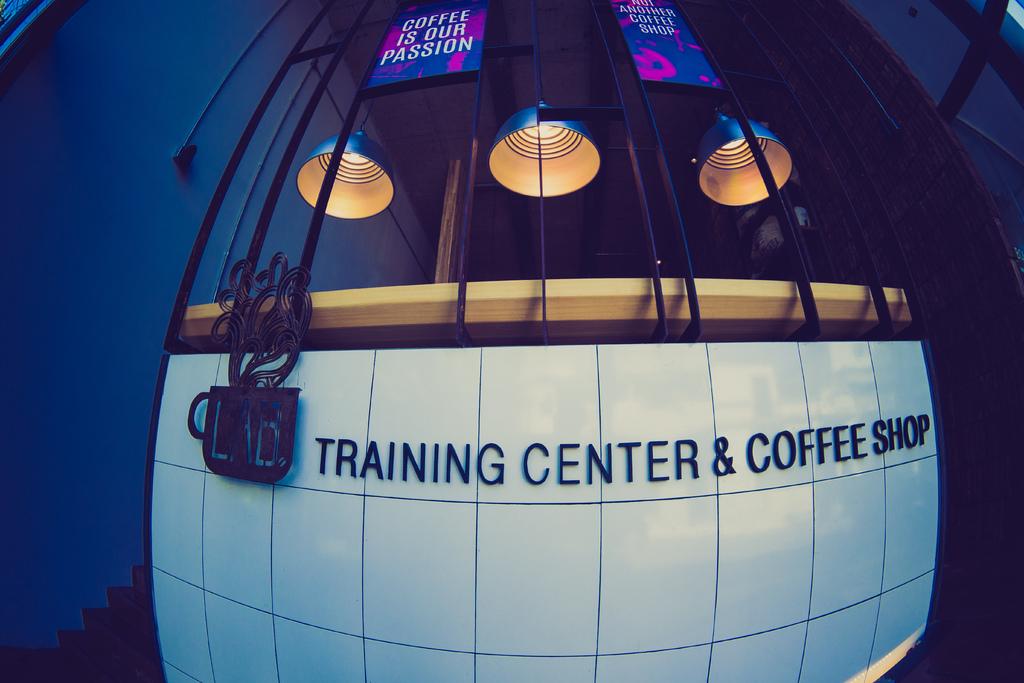What does this shop sell?
Keep it short and to the point. Coffee. What is the name of this place?
Offer a terse response. Training center & coffee shop. 